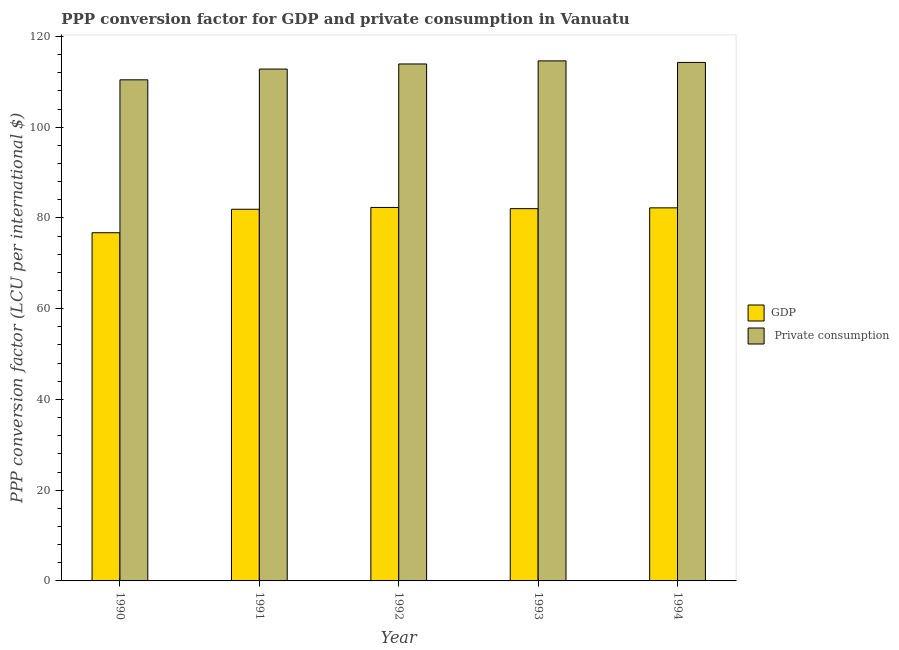How many different coloured bars are there?
Make the answer very short. 2. How many groups of bars are there?
Offer a very short reply. 5. Are the number of bars on each tick of the X-axis equal?
Offer a terse response. Yes. What is the label of the 3rd group of bars from the left?
Offer a very short reply. 1992. What is the ppp conversion factor for private consumption in 1990?
Keep it short and to the point. 110.45. Across all years, what is the maximum ppp conversion factor for gdp?
Give a very brief answer. 82.32. Across all years, what is the minimum ppp conversion factor for gdp?
Offer a very short reply. 76.74. In which year was the ppp conversion factor for gdp minimum?
Offer a terse response. 1990. What is the total ppp conversion factor for gdp in the graph?
Provide a succinct answer. 405.26. What is the difference between the ppp conversion factor for private consumption in 1990 and that in 1991?
Offer a very short reply. -2.37. What is the difference between the ppp conversion factor for private consumption in 1992 and the ppp conversion factor for gdp in 1991?
Offer a very short reply. 1.13. What is the average ppp conversion factor for gdp per year?
Offer a very short reply. 81.05. In how many years, is the ppp conversion factor for private consumption greater than 96 LCU?
Make the answer very short. 5. What is the ratio of the ppp conversion factor for gdp in 1990 to that in 1993?
Ensure brevity in your answer.  0.94. Is the ppp conversion factor for gdp in 1990 less than that in 1994?
Your answer should be very brief. Yes. Is the difference between the ppp conversion factor for private consumption in 1991 and 1994 greater than the difference between the ppp conversion factor for gdp in 1991 and 1994?
Make the answer very short. No. What is the difference between the highest and the second highest ppp conversion factor for gdp?
Make the answer very short. 0.09. What is the difference between the highest and the lowest ppp conversion factor for gdp?
Offer a terse response. 5.57. What does the 2nd bar from the left in 1991 represents?
Give a very brief answer.  Private consumption. What does the 1st bar from the right in 1991 represents?
Provide a short and direct response.  Private consumption. What is the difference between two consecutive major ticks on the Y-axis?
Give a very brief answer. 20. Does the graph contain grids?
Provide a short and direct response. No. How are the legend labels stacked?
Ensure brevity in your answer.  Vertical. What is the title of the graph?
Make the answer very short. PPP conversion factor for GDP and private consumption in Vanuatu. Does "Resident workers" appear as one of the legend labels in the graph?
Offer a very short reply. No. What is the label or title of the Y-axis?
Offer a very short reply. PPP conversion factor (LCU per international $). What is the PPP conversion factor (LCU per international $) of GDP in 1990?
Provide a short and direct response. 76.74. What is the PPP conversion factor (LCU per international $) in  Private consumption in 1990?
Keep it short and to the point. 110.45. What is the PPP conversion factor (LCU per international $) in GDP in 1991?
Your response must be concise. 81.92. What is the PPP conversion factor (LCU per international $) of  Private consumption in 1991?
Keep it short and to the point. 112.81. What is the PPP conversion factor (LCU per international $) of GDP in 1992?
Your answer should be compact. 82.32. What is the PPP conversion factor (LCU per international $) in  Private consumption in 1992?
Your answer should be compact. 113.94. What is the PPP conversion factor (LCU per international $) in GDP in 1993?
Your response must be concise. 82.05. What is the PPP conversion factor (LCU per international $) in  Private consumption in 1993?
Make the answer very short. 114.62. What is the PPP conversion factor (LCU per international $) of GDP in 1994?
Make the answer very short. 82.23. What is the PPP conversion factor (LCU per international $) in  Private consumption in 1994?
Your answer should be compact. 114.28. Across all years, what is the maximum PPP conversion factor (LCU per international $) in GDP?
Offer a very short reply. 82.32. Across all years, what is the maximum PPP conversion factor (LCU per international $) in  Private consumption?
Your answer should be compact. 114.62. Across all years, what is the minimum PPP conversion factor (LCU per international $) of GDP?
Keep it short and to the point. 76.74. Across all years, what is the minimum PPP conversion factor (LCU per international $) of  Private consumption?
Offer a very short reply. 110.45. What is the total PPP conversion factor (LCU per international $) in GDP in the graph?
Give a very brief answer. 405.26. What is the total PPP conversion factor (LCU per international $) of  Private consumption in the graph?
Make the answer very short. 566.11. What is the difference between the PPP conversion factor (LCU per international $) of GDP in 1990 and that in 1991?
Offer a very short reply. -5.17. What is the difference between the PPP conversion factor (LCU per international $) of  Private consumption in 1990 and that in 1991?
Make the answer very short. -2.37. What is the difference between the PPP conversion factor (LCU per international $) of GDP in 1990 and that in 1992?
Provide a succinct answer. -5.57. What is the difference between the PPP conversion factor (LCU per international $) of  Private consumption in 1990 and that in 1992?
Make the answer very short. -3.49. What is the difference between the PPP conversion factor (LCU per international $) in GDP in 1990 and that in 1993?
Your response must be concise. -5.31. What is the difference between the PPP conversion factor (LCU per international $) of  Private consumption in 1990 and that in 1993?
Your answer should be compact. -4.17. What is the difference between the PPP conversion factor (LCU per international $) in GDP in 1990 and that in 1994?
Keep it short and to the point. -5.48. What is the difference between the PPP conversion factor (LCU per international $) in  Private consumption in 1990 and that in 1994?
Offer a terse response. -3.83. What is the difference between the PPP conversion factor (LCU per international $) of GDP in 1991 and that in 1992?
Your answer should be compact. -0.4. What is the difference between the PPP conversion factor (LCU per international $) of  Private consumption in 1991 and that in 1992?
Make the answer very short. -1.13. What is the difference between the PPP conversion factor (LCU per international $) in GDP in 1991 and that in 1993?
Provide a succinct answer. -0.13. What is the difference between the PPP conversion factor (LCU per international $) of  Private consumption in 1991 and that in 1993?
Keep it short and to the point. -1.81. What is the difference between the PPP conversion factor (LCU per international $) in GDP in 1991 and that in 1994?
Offer a very short reply. -0.31. What is the difference between the PPP conversion factor (LCU per international $) of  Private consumption in 1991 and that in 1994?
Your answer should be compact. -1.47. What is the difference between the PPP conversion factor (LCU per international $) of GDP in 1992 and that in 1993?
Keep it short and to the point. 0.27. What is the difference between the PPP conversion factor (LCU per international $) of  Private consumption in 1992 and that in 1993?
Your answer should be compact. -0.68. What is the difference between the PPP conversion factor (LCU per international $) of GDP in 1992 and that in 1994?
Your answer should be very brief. 0.09. What is the difference between the PPP conversion factor (LCU per international $) in  Private consumption in 1992 and that in 1994?
Your answer should be very brief. -0.34. What is the difference between the PPP conversion factor (LCU per international $) in GDP in 1993 and that in 1994?
Your answer should be very brief. -0.18. What is the difference between the PPP conversion factor (LCU per international $) of  Private consumption in 1993 and that in 1994?
Give a very brief answer. 0.34. What is the difference between the PPP conversion factor (LCU per international $) in GDP in 1990 and the PPP conversion factor (LCU per international $) in  Private consumption in 1991?
Provide a short and direct response. -36.07. What is the difference between the PPP conversion factor (LCU per international $) in GDP in 1990 and the PPP conversion factor (LCU per international $) in  Private consumption in 1992?
Provide a succinct answer. -37.2. What is the difference between the PPP conversion factor (LCU per international $) in GDP in 1990 and the PPP conversion factor (LCU per international $) in  Private consumption in 1993?
Provide a succinct answer. -37.88. What is the difference between the PPP conversion factor (LCU per international $) in GDP in 1990 and the PPP conversion factor (LCU per international $) in  Private consumption in 1994?
Provide a succinct answer. -37.54. What is the difference between the PPP conversion factor (LCU per international $) of GDP in 1991 and the PPP conversion factor (LCU per international $) of  Private consumption in 1992?
Give a very brief answer. -32.02. What is the difference between the PPP conversion factor (LCU per international $) in GDP in 1991 and the PPP conversion factor (LCU per international $) in  Private consumption in 1993?
Your answer should be very brief. -32.7. What is the difference between the PPP conversion factor (LCU per international $) of GDP in 1991 and the PPP conversion factor (LCU per international $) of  Private consumption in 1994?
Your response must be concise. -32.36. What is the difference between the PPP conversion factor (LCU per international $) in GDP in 1992 and the PPP conversion factor (LCU per international $) in  Private consumption in 1993?
Keep it short and to the point. -32.3. What is the difference between the PPP conversion factor (LCU per international $) of GDP in 1992 and the PPP conversion factor (LCU per international $) of  Private consumption in 1994?
Make the answer very short. -31.96. What is the difference between the PPP conversion factor (LCU per international $) of GDP in 1993 and the PPP conversion factor (LCU per international $) of  Private consumption in 1994?
Your answer should be very brief. -32.23. What is the average PPP conversion factor (LCU per international $) of GDP per year?
Give a very brief answer. 81.05. What is the average PPP conversion factor (LCU per international $) of  Private consumption per year?
Ensure brevity in your answer.  113.22. In the year 1990, what is the difference between the PPP conversion factor (LCU per international $) of GDP and PPP conversion factor (LCU per international $) of  Private consumption?
Make the answer very short. -33.7. In the year 1991, what is the difference between the PPP conversion factor (LCU per international $) of GDP and PPP conversion factor (LCU per international $) of  Private consumption?
Provide a short and direct response. -30.9. In the year 1992, what is the difference between the PPP conversion factor (LCU per international $) in GDP and PPP conversion factor (LCU per international $) in  Private consumption?
Your response must be concise. -31.62. In the year 1993, what is the difference between the PPP conversion factor (LCU per international $) in GDP and PPP conversion factor (LCU per international $) in  Private consumption?
Provide a succinct answer. -32.57. In the year 1994, what is the difference between the PPP conversion factor (LCU per international $) of GDP and PPP conversion factor (LCU per international $) of  Private consumption?
Offer a very short reply. -32.05. What is the ratio of the PPP conversion factor (LCU per international $) of GDP in 1990 to that in 1991?
Make the answer very short. 0.94. What is the ratio of the PPP conversion factor (LCU per international $) in GDP in 1990 to that in 1992?
Your response must be concise. 0.93. What is the ratio of the PPP conversion factor (LCU per international $) in  Private consumption in 1990 to that in 1992?
Offer a terse response. 0.97. What is the ratio of the PPP conversion factor (LCU per international $) in GDP in 1990 to that in 1993?
Provide a short and direct response. 0.94. What is the ratio of the PPP conversion factor (LCU per international $) in  Private consumption in 1990 to that in 1993?
Make the answer very short. 0.96. What is the ratio of the PPP conversion factor (LCU per international $) in  Private consumption in 1990 to that in 1994?
Provide a short and direct response. 0.97. What is the ratio of the PPP conversion factor (LCU per international $) of GDP in 1991 to that in 1992?
Offer a very short reply. 1. What is the ratio of the PPP conversion factor (LCU per international $) in  Private consumption in 1991 to that in 1993?
Offer a very short reply. 0.98. What is the ratio of the PPP conversion factor (LCU per international $) in  Private consumption in 1991 to that in 1994?
Give a very brief answer. 0.99. What is the ratio of the PPP conversion factor (LCU per international $) in GDP in 1992 to that in 1993?
Offer a terse response. 1. What is the ratio of the PPP conversion factor (LCU per international $) of  Private consumption in 1993 to that in 1994?
Give a very brief answer. 1. What is the difference between the highest and the second highest PPP conversion factor (LCU per international $) in GDP?
Your response must be concise. 0.09. What is the difference between the highest and the second highest PPP conversion factor (LCU per international $) of  Private consumption?
Make the answer very short. 0.34. What is the difference between the highest and the lowest PPP conversion factor (LCU per international $) in GDP?
Your answer should be very brief. 5.57. What is the difference between the highest and the lowest PPP conversion factor (LCU per international $) of  Private consumption?
Provide a succinct answer. 4.17. 